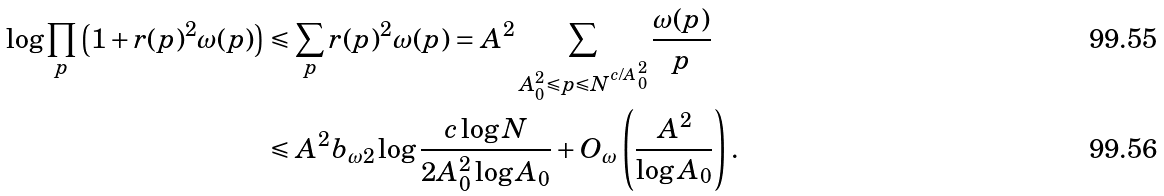Convert formula to latex. <formula><loc_0><loc_0><loc_500><loc_500>\log \prod _ { p } \left ( 1 + r ( p ) ^ { 2 } \omega ( p ) \right ) & \leqslant \sum _ { p } r ( p ) ^ { 2 } \omega ( p ) = A ^ { 2 } \sum _ { A _ { 0 } ^ { 2 } \leqslant p \leqslant N ^ { c / A _ { 0 } ^ { 2 } } } \frac { \omega ( p ) } p \\ & \leqslant A ^ { 2 } b _ { \omega 2 } \log \frac { c \log N } { 2 A _ { 0 } ^ { 2 } \log A _ { 0 } } + O _ { \omega } \left ( \frac { A ^ { 2 } } { \log A _ { 0 } } \right ) .</formula> 